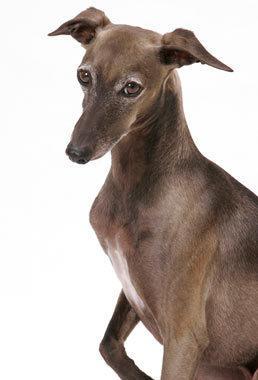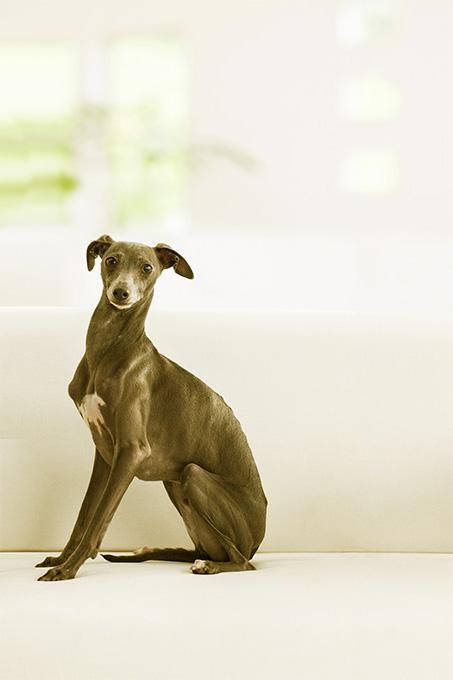The first image is the image on the left, the second image is the image on the right. Evaluate the accuracy of this statement regarding the images: "In one of the images, there is a brown and white dog standing in grass". Is it true? Answer yes or no. No. 